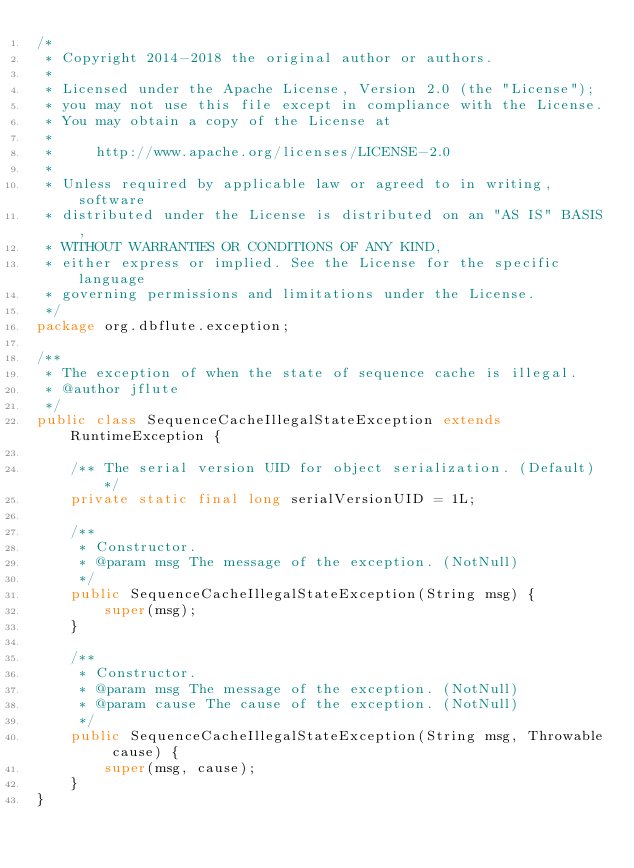<code> <loc_0><loc_0><loc_500><loc_500><_Java_>/*
 * Copyright 2014-2018 the original author or authors.
 *
 * Licensed under the Apache License, Version 2.0 (the "License");
 * you may not use this file except in compliance with the License.
 * You may obtain a copy of the License at
 *
 *     http://www.apache.org/licenses/LICENSE-2.0
 *
 * Unless required by applicable law or agreed to in writing, software
 * distributed under the License is distributed on an "AS IS" BASIS,
 * WITHOUT WARRANTIES OR CONDITIONS OF ANY KIND,
 * either express or implied. See the License for the specific language
 * governing permissions and limitations under the License.
 */
package org.dbflute.exception;

/**
 * The exception of when the state of sequence cache is illegal.
 * @author jflute
 */
public class SequenceCacheIllegalStateException extends RuntimeException {

    /** The serial version UID for object serialization. (Default) */
    private static final long serialVersionUID = 1L;

    /**
     * Constructor.
     * @param msg The message of the exception. (NotNull)
     */
    public SequenceCacheIllegalStateException(String msg) {
        super(msg);
    }

    /**
     * Constructor.
     * @param msg The message of the exception. (NotNull)
     * @param cause The cause of the exception. (NotNull)
     */
    public SequenceCacheIllegalStateException(String msg, Throwable cause) {
        super(msg, cause);
    }
}
</code> 